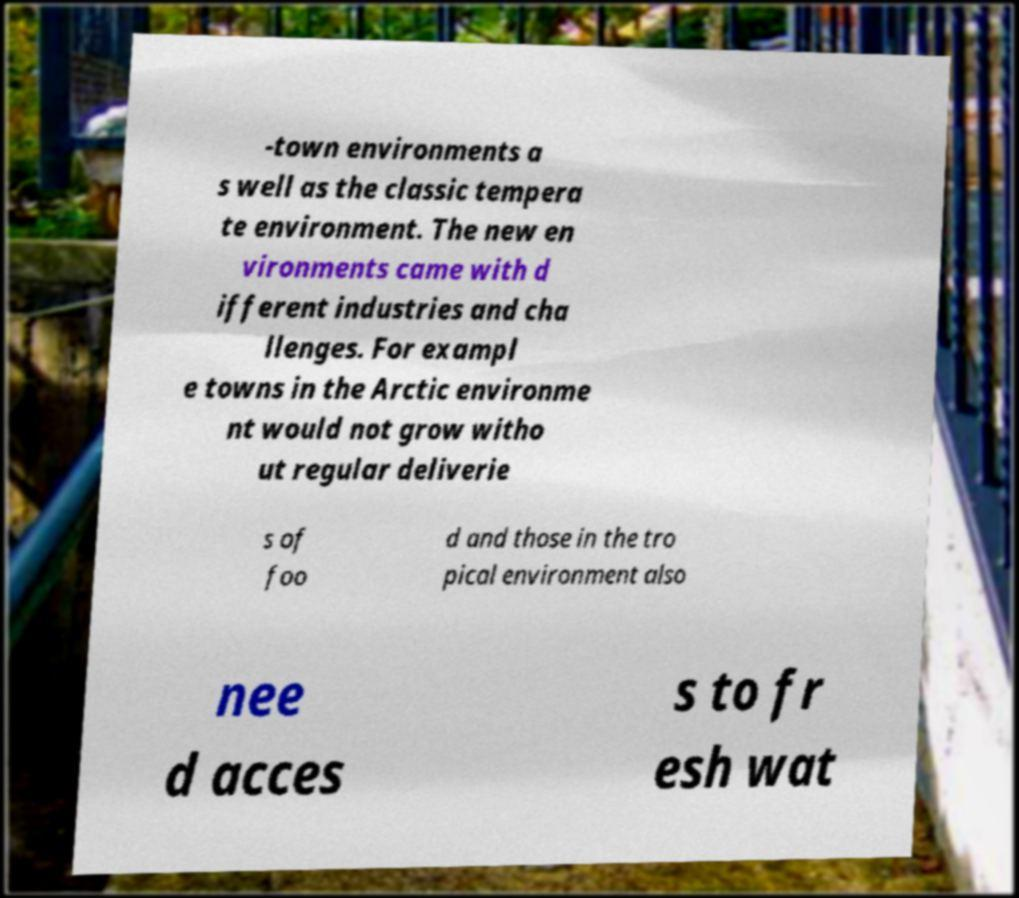Can you accurately transcribe the text from the provided image for me? -town environments a s well as the classic tempera te environment. The new en vironments came with d ifferent industries and cha llenges. For exampl e towns in the Arctic environme nt would not grow witho ut regular deliverie s of foo d and those in the tro pical environment also nee d acces s to fr esh wat 